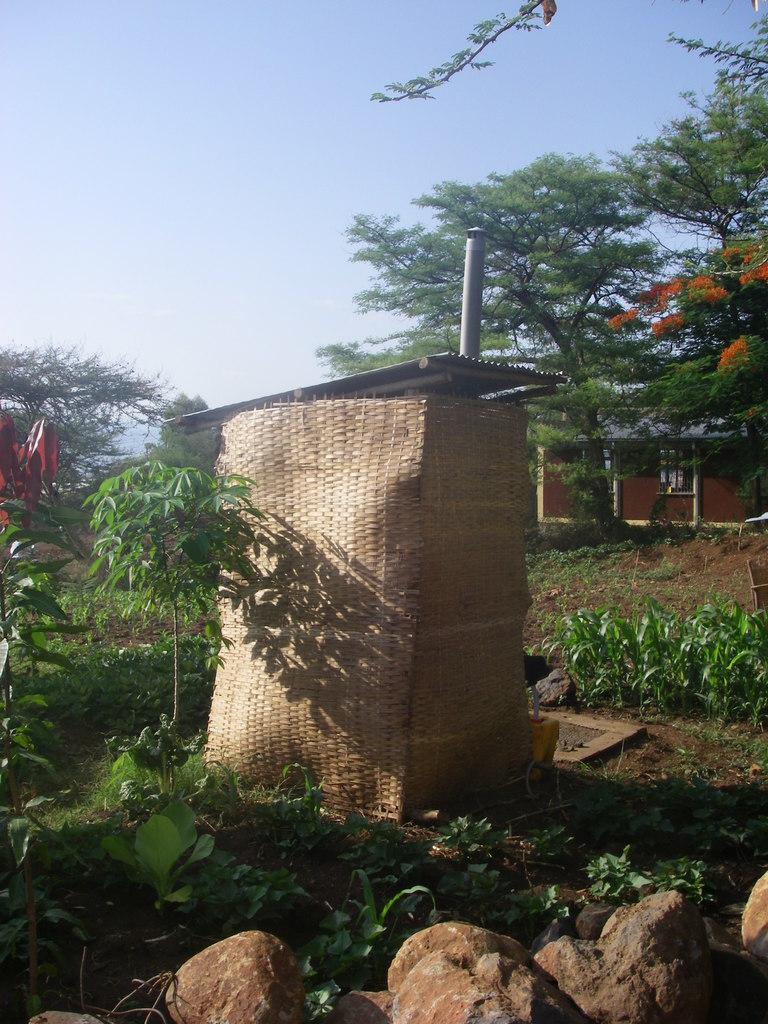Describe this image in one or two sentences. In this image in front there are rocks. At the center of the image there is a shed. We can see plants and at the bottom there is grass on the surface. In the background there are trees, building and sky. 